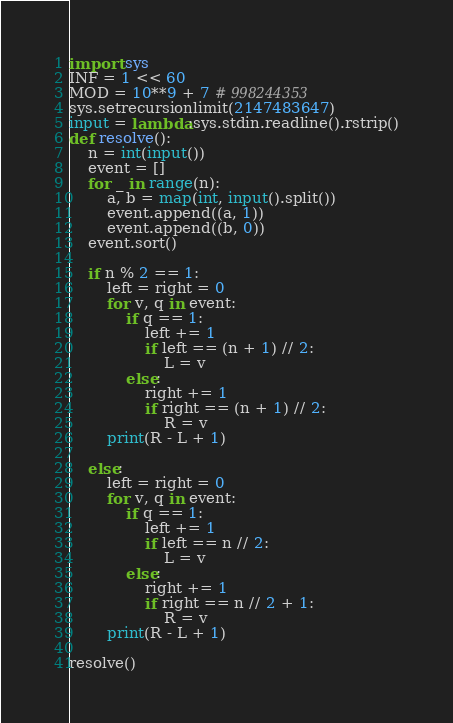Convert code to text. <code><loc_0><loc_0><loc_500><loc_500><_Python_>import sys
INF = 1 << 60
MOD = 10**9 + 7 # 998244353
sys.setrecursionlimit(2147483647)
input = lambda:sys.stdin.readline().rstrip()
def resolve():
    n = int(input())
    event = []
    for _ in range(n):
        a, b = map(int, input().split())
        event.append((a, 1))
        event.append((b, 0))
    event.sort()

    if n % 2 == 1:
        left = right = 0
        for v, q in event:
            if q == 1:
                left += 1
                if left == (n + 1) // 2:
                    L = v
            else:
                right += 1
                if right == (n + 1) // 2:
                    R = v
        print(R - L + 1)

    else:
        left = right = 0
        for v, q in event:
            if q == 1:
                left += 1
                if left == n // 2:
                    L = v
            else:
                right += 1
                if right == n // 2 + 1:
                    R = v
        print(R - L + 1)

resolve()</code> 